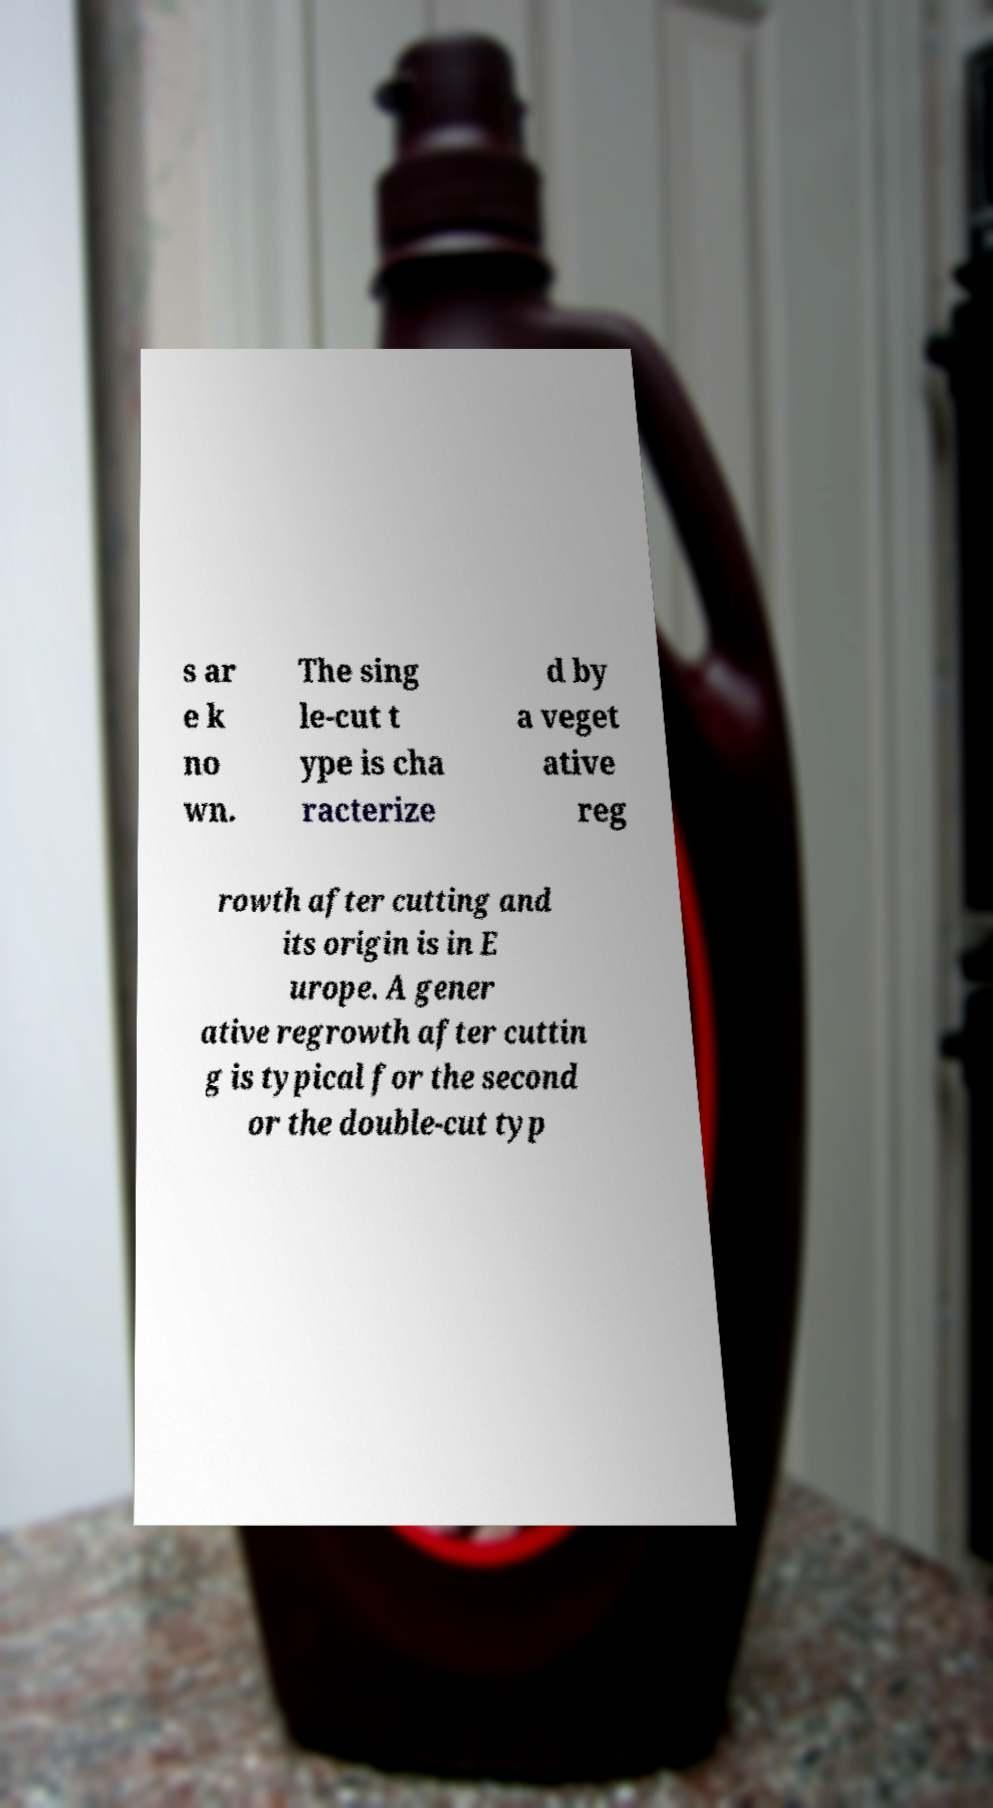For documentation purposes, I need the text within this image transcribed. Could you provide that? s ar e k no wn. The sing le-cut t ype is cha racterize d by a veget ative reg rowth after cutting and its origin is in E urope. A gener ative regrowth after cuttin g is typical for the second or the double-cut typ 